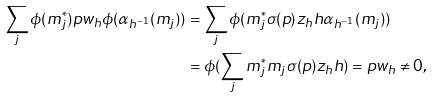Convert formula to latex. <formula><loc_0><loc_0><loc_500><loc_500>\sum _ { j } \phi ( m _ { j } ^ { * } ) p w _ { h } \phi ( \alpha _ { h ^ { - 1 } } ( m _ { j } ) ) & = \sum _ { j } \phi ( m _ { j } ^ { * } \sigma ( p ) z _ { h } h \alpha _ { h ^ { - 1 } } ( m _ { j } ) ) \\ & = \phi ( \sum _ { j } m _ { j } ^ { * } m _ { j } \sigma ( p ) z _ { h } h ) = p w _ { h } \ne 0 ,</formula> 